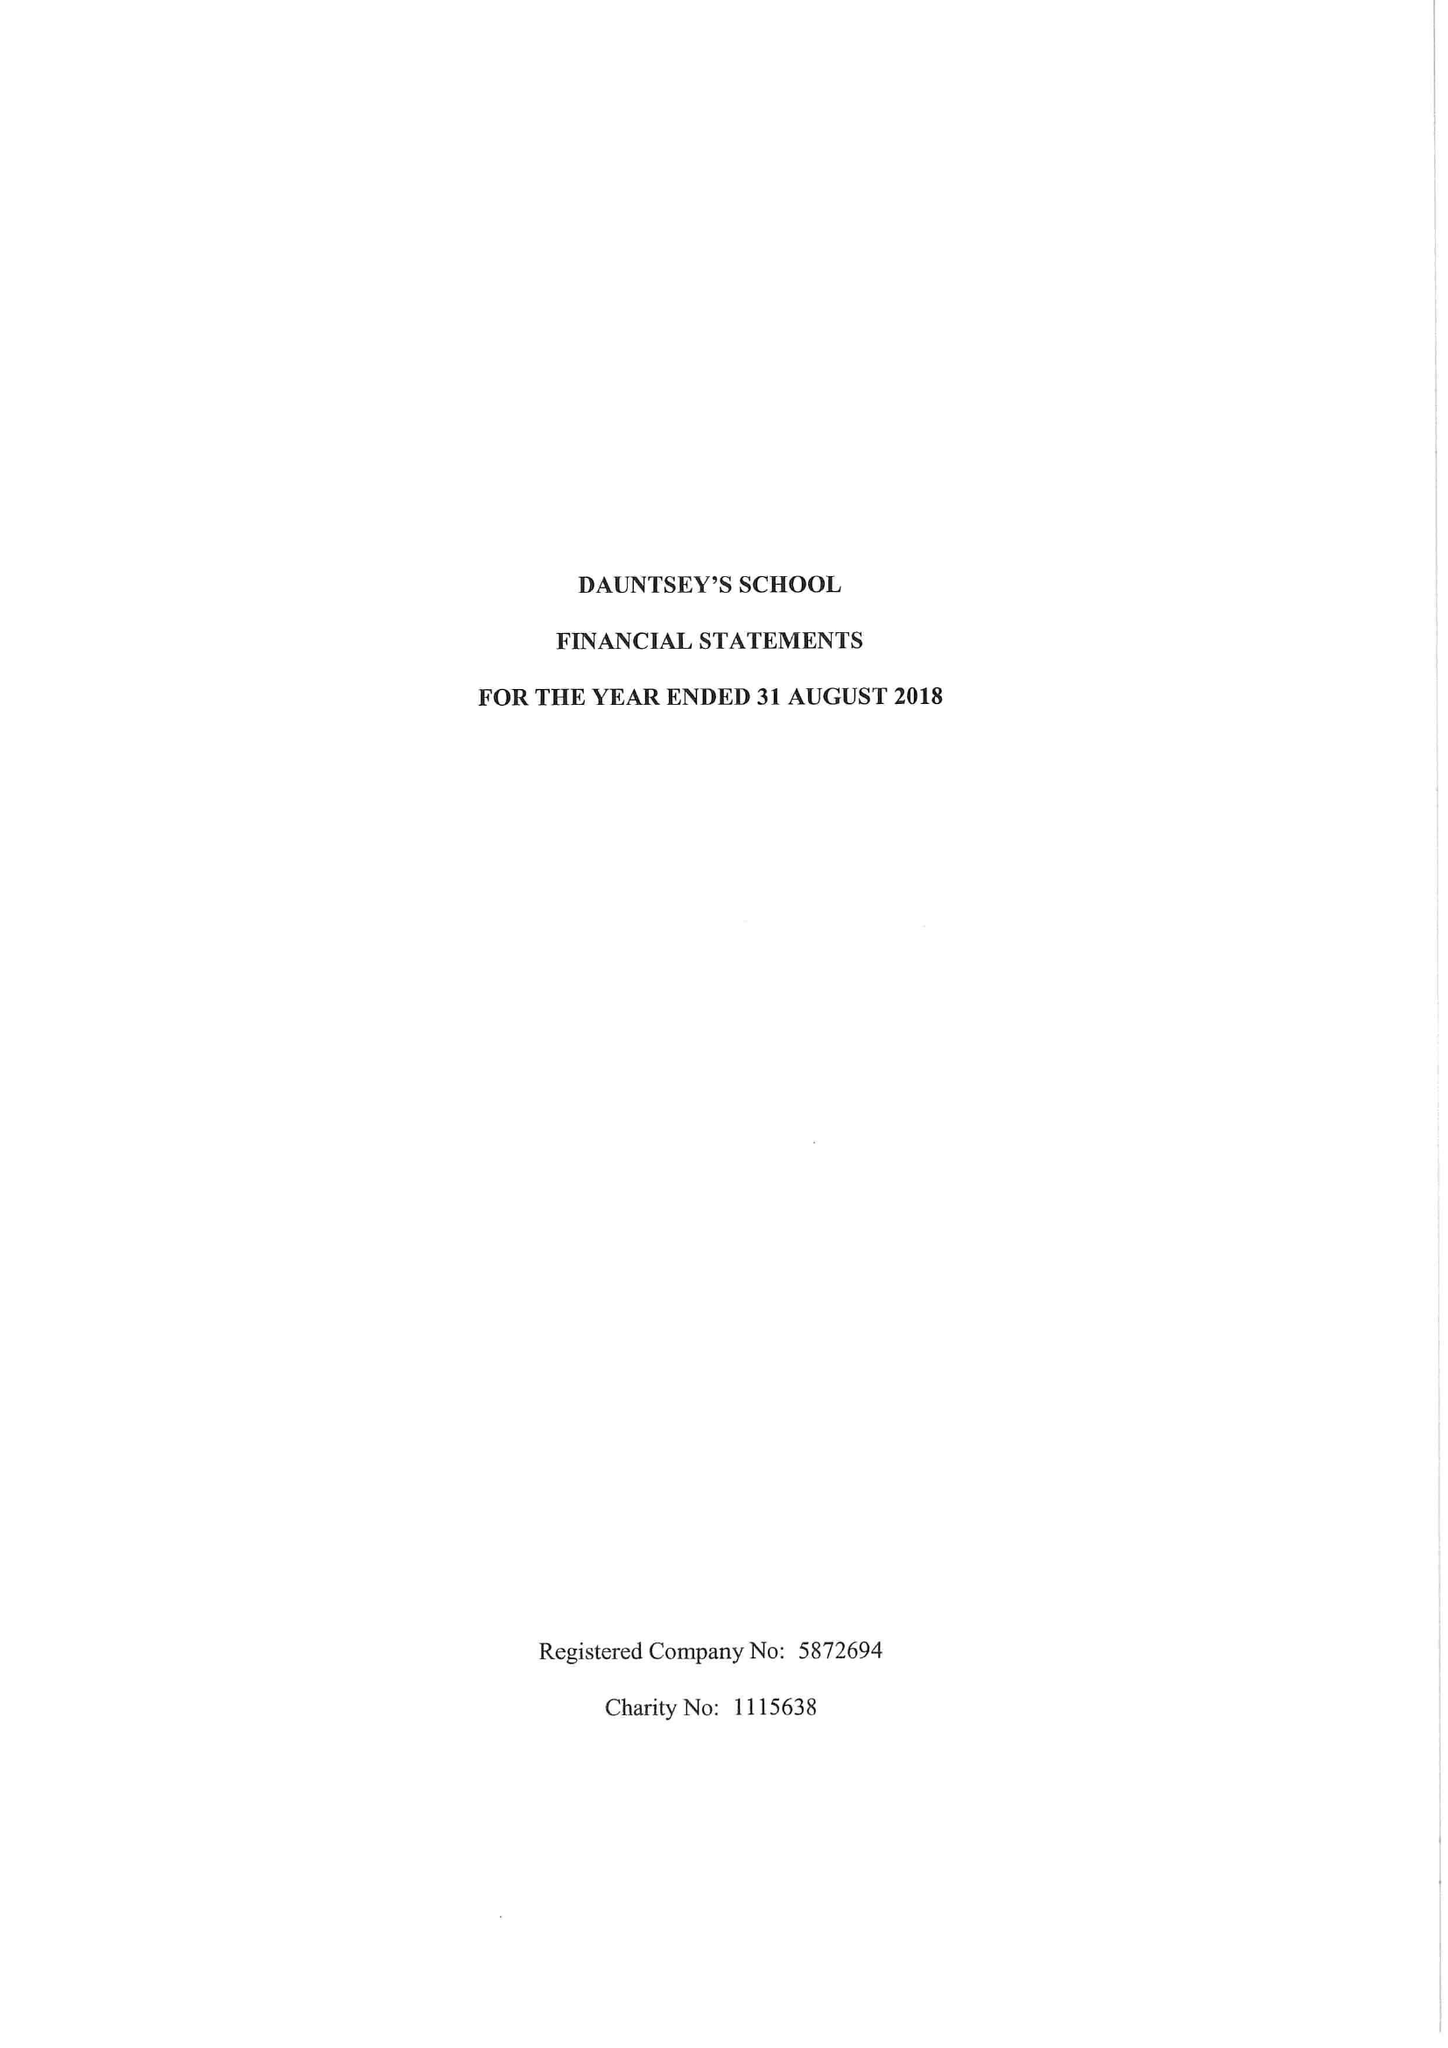What is the value for the report_date?
Answer the question using a single word or phrase. 2018-08-31 